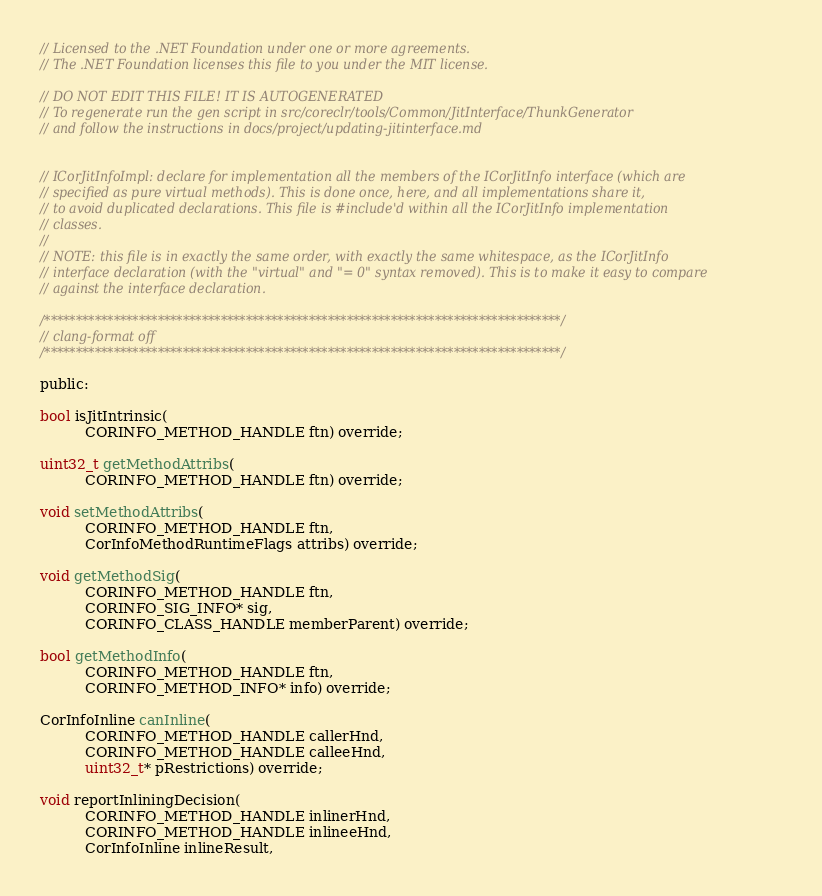<code> <loc_0><loc_0><loc_500><loc_500><_C_>// Licensed to the .NET Foundation under one or more agreements.
// The .NET Foundation licenses this file to you under the MIT license.

// DO NOT EDIT THIS FILE! IT IS AUTOGENERATED
// To regenerate run the gen script in src/coreclr/tools/Common/JitInterface/ThunkGenerator
// and follow the instructions in docs/project/updating-jitinterface.md


// ICorJitInfoImpl: declare for implementation all the members of the ICorJitInfo interface (which are
// specified as pure virtual methods). This is done once, here, and all implementations share it,
// to avoid duplicated declarations. This file is #include'd within all the ICorJitInfo implementation
// classes.
//
// NOTE: this file is in exactly the same order, with exactly the same whitespace, as the ICorJitInfo
// interface declaration (with the "virtual" and "= 0" syntax removed). This is to make it easy to compare
// against the interface declaration.

/**********************************************************************************/
// clang-format off
/**********************************************************************************/

public:

bool isJitIntrinsic(
          CORINFO_METHOD_HANDLE ftn) override;

uint32_t getMethodAttribs(
          CORINFO_METHOD_HANDLE ftn) override;

void setMethodAttribs(
          CORINFO_METHOD_HANDLE ftn,
          CorInfoMethodRuntimeFlags attribs) override;

void getMethodSig(
          CORINFO_METHOD_HANDLE ftn,
          CORINFO_SIG_INFO* sig,
          CORINFO_CLASS_HANDLE memberParent) override;

bool getMethodInfo(
          CORINFO_METHOD_HANDLE ftn,
          CORINFO_METHOD_INFO* info) override;

CorInfoInline canInline(
          CORINFO_METHOD_HANDLE callerHnd,
          CORINFO_METHOD_HANDLE calleeHnd,
          uint32_t* pRestrictions) override;

void reportInliningDecision(
          CORINFO_METHOD_HANDLE inlinerHnd,
          CORINFO_METHOD_HANDLE inlineeHnd,
          CorInfoInline inlineResult,</code> 